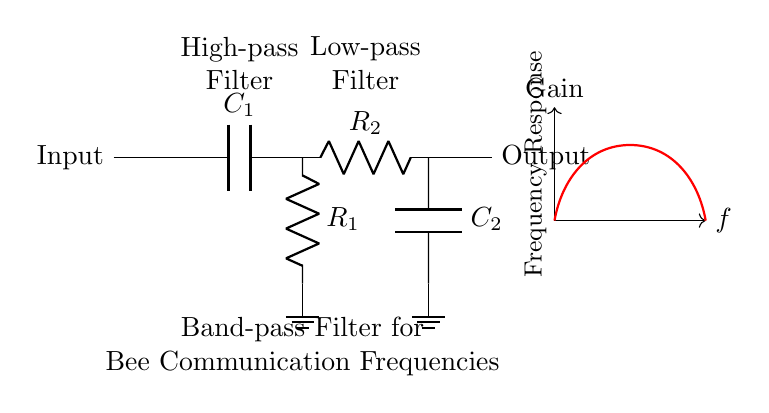What type of filter is represented in this circuit? The circuit diagram shows a band-pass filter, which is indicated by the labeling and the combination of both high-pass and low-pass filter sections.
Answer: Band-pass What components are used in the high-pass filter section? In the high-pass filter section, there is a capacitor labeled C1 and a resistor labeled R1 connecting to ground.
Answer: Capacitor and resistor What is the function of the capacitor C2 in this circuit? The capacitor C2 is part of the low-pass filter section; its function is to allow low-frequency signals to pass while blocking higher frequencies.
Answer: Allow low frequencies What is the position of the ground in this circuit? The ground is positioned at the bottom of the circuit at both the high-pass and low-pass filter sections, indicating a common reference point for both filters.
Answer: Bottom of the circuit How many resistors are present in this circuit? The circuit contains two resistors: R1 and R2, each associated with their respective filter sections.
Answer: Two What is the role of the high-pass filter in this circuit? The high-pass filter's role is to block low-frequency signals and allow higher frequency signals, specifically those associated with bee communication, to pass to the output.
Answer: Block low frequencies What does the frequency response curve depict? The frequency response curve shows the gain of the band-pass filter in relation to frequency, indicating the range of frequencies that the filter will amplify.
Answer: Gain vs. frequency 